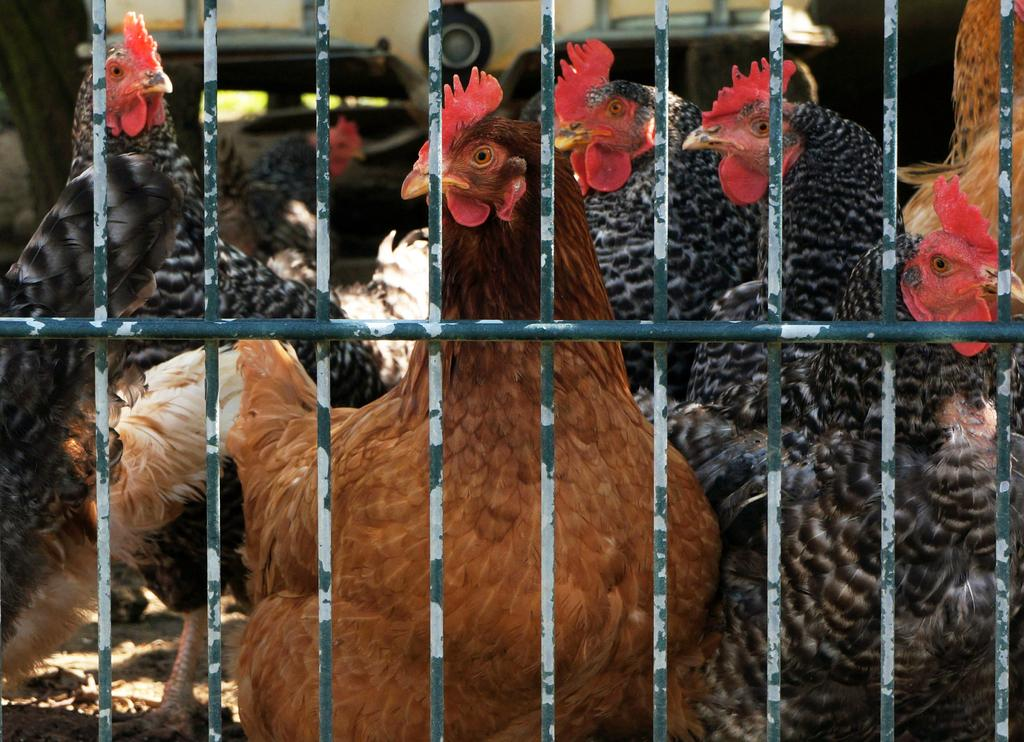What animals are present in the image? There is a group of cocks in the image. What type of fence can be seen in the image? There is a fence made of iron rods in the image. What type of straw is being used by the cocks to balance in the image? There is no straw present in the image, and the cocks are not balancing on anything. 